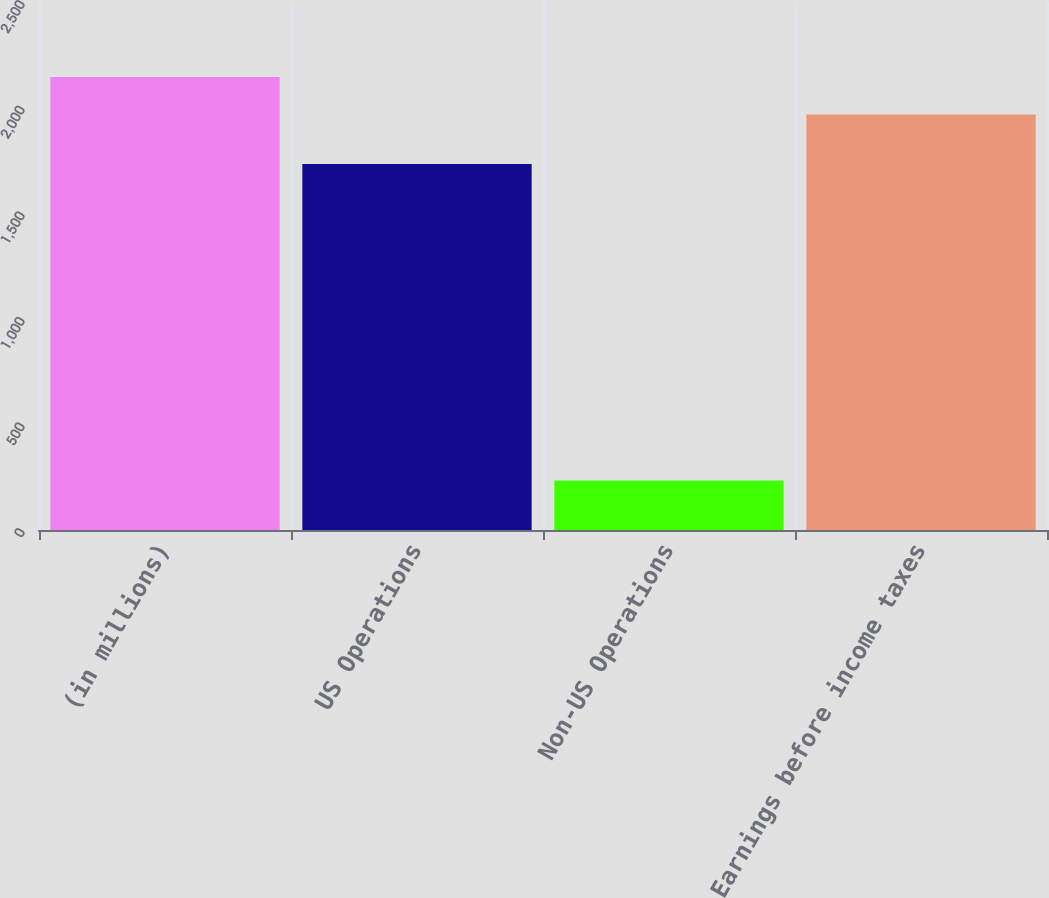<chart> <loc_0><loc_0><loc_500><loc_500><bar_chart><fcel>(in millions)<fcel>US Operations<fcel>Non-US Operations<fcel>Earnings before income taxes<nl><fcel>2145.1<fcel>1733<fcel>234<fcel>1967<nl></chart> 